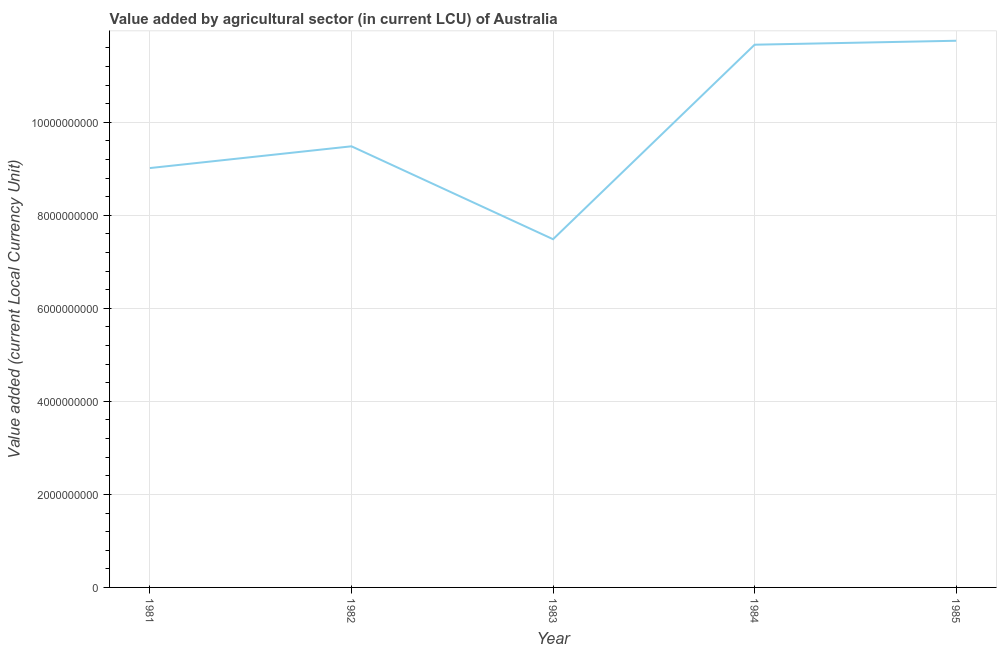What is the value added by agriculture sector in 1985?
Offer a terse response. 1.18e+1. Across all years, what is the maximum value added by agriculture sector?
Keep it short and to the point. 1.18e+1. Across all years, what is the minimum value added by agriculture sector?
Provide a succinct answer. 7.49e+09. In which year was the value added by agriculture sector minimum?
Ensure brevity in your answer.  1983. What is the sum of the value added by agriculture sector?
Keep it short and to the point. 4.94e+1. What is the difference between the value added by agriculture sector in 1984 and 1985?
Your answer should be compact. -8.50e+07. What is the average value added by agriculture sector per year?
Your answer should be compact. 9.88e+09. What is the median value added by agriculture sector?
Offer a very short reply. 9.48e+09. What is the ratio of the value added by agriculture sector in 1983 to that in 1985?
Your response must be concise. 0.64. Is the difference between the value added by agriculture sector in 1982 and 1984 greater than the difference between any two years?
Make the answer very short. No. What is the difference between the highest and the second highest value added by agriculture sector?
Give a very brief answer. 8.50e+07. What is the difference between the highest and the lowest value added by agriculture sector?
Your answer should be very brief. 4.27e+09. In how many years, is the value added by agriculture sector greater than the average value added by agriculture sector taken over all years?
Your response must be concise. 2. Does the value added by agriculture sector monotonically increase over the years?
Make the answer very short. No. Does the graph contain any zero values?
Give a very brief answer. No. What is the title of the graph?
Your answer should be compact. Value added by agricultural sector (in current LCU) of Australia. What is the label or title of the X-axis?
Give a very brief answer. Year. What is the label or title of the Y-axis?
Offer a terse response. Value added (current Local Currency Unit). What is the Value added (current Local Currency Unit) in 1981?
Your answer should be very brief. 9.02e+09. What is the Value added (current Local Currency Unit) in 1982?
Offer a terse response. 9.48e+09. What is the Value added (current Local Currency Unit) of 1983?
Offer a very short reply. 7.49e+09. What is the Value added (current Local Currency Unit) in 1984?
Provide a short and direct response. 1.17e+1. What is the Value added (current Local Currency Unit) in 1985?
Your response must be concise. 1.18e+1. What is the difference between the Value added (current Local Currency Unit) in 1981 and 1982?
Your response must be concise. -4.68e+08. What is the difference between the Value added (current Local Currency Unit) in 1981 and 1983?
Offer a very short reply. 1.53e+09. What is the difference between the Value added (current Local Currency Unit) in 1981 and 1984?
Ensure brevity in your answer.  -2.65e+09. What is the difference between the Value added (current Local Currency Unit) in 1981 and 1985?
Make the answer very short. -2.74e+09. What is the difference between the Value added (current Local Currency Unit) in 1982 and 1983?
Your answer should be compact. 2.00e+09. What is the difference between the Value added (current Local Currency Unit) in 1982 and 1984?
Your response must be concise. -2.18e+09. What is the difference between the Value added (current Local Currency Unit) in 1982 and 1985?
Provide a short and direct response. -2.27e+09. What is the difference between the Value added (current Local Currency Unit) in 1983 and 1984?
Make the answer very short. -4.18e+09. What is the difference between the Value added (current Local Currency Unit) in 1983 and 1985?
Make the answer very short. -4.27e+09. What is the difference between the Value added (current Local Currency Unit) in 1984 and 1985?
Give a very brief answer. -8.50e+07. What is the ratio of the Value added (current Local Currency Unit) in 1981 to that in 1982?
Provide a succinct answer. 0.95. What is the ratio of the Value added (current Local Currency Unit) in 1981 to that in 1983?
Ensure brevity in your answer.  1.2. What is the ratio of the Value added (current Local Currency Unit) in 1981 to that in 1984?
Keep it short and to the point. 0.77. What is the ratio of the Value added (current Local Currency Unit) in 1981 to that in 1985?
Offer a terse response. 0.77. What is the ratio of the Value added (current Local Currency Unit) in 1982 to that in 1983?
Offer a very short reply. 1.27. What is the ratio of the Value added (current Local Currency Unit) in 1982 to that in 1984?
Offer a very short reply. 0.81. What is the ratio of the Value added (current Local Currency Unit) in 1982 to that in 1985?
Keep it short and to the point. 0.81. What is the ratio of the Value added (current Local Currency Unit) in 1983 to that in 1984?
Your answer should be very brief. 0.64. What is the ratio of the Value added (current Local Currency Unit) in 1983 to that in 1985?
Offer a terse response. 0.64. 